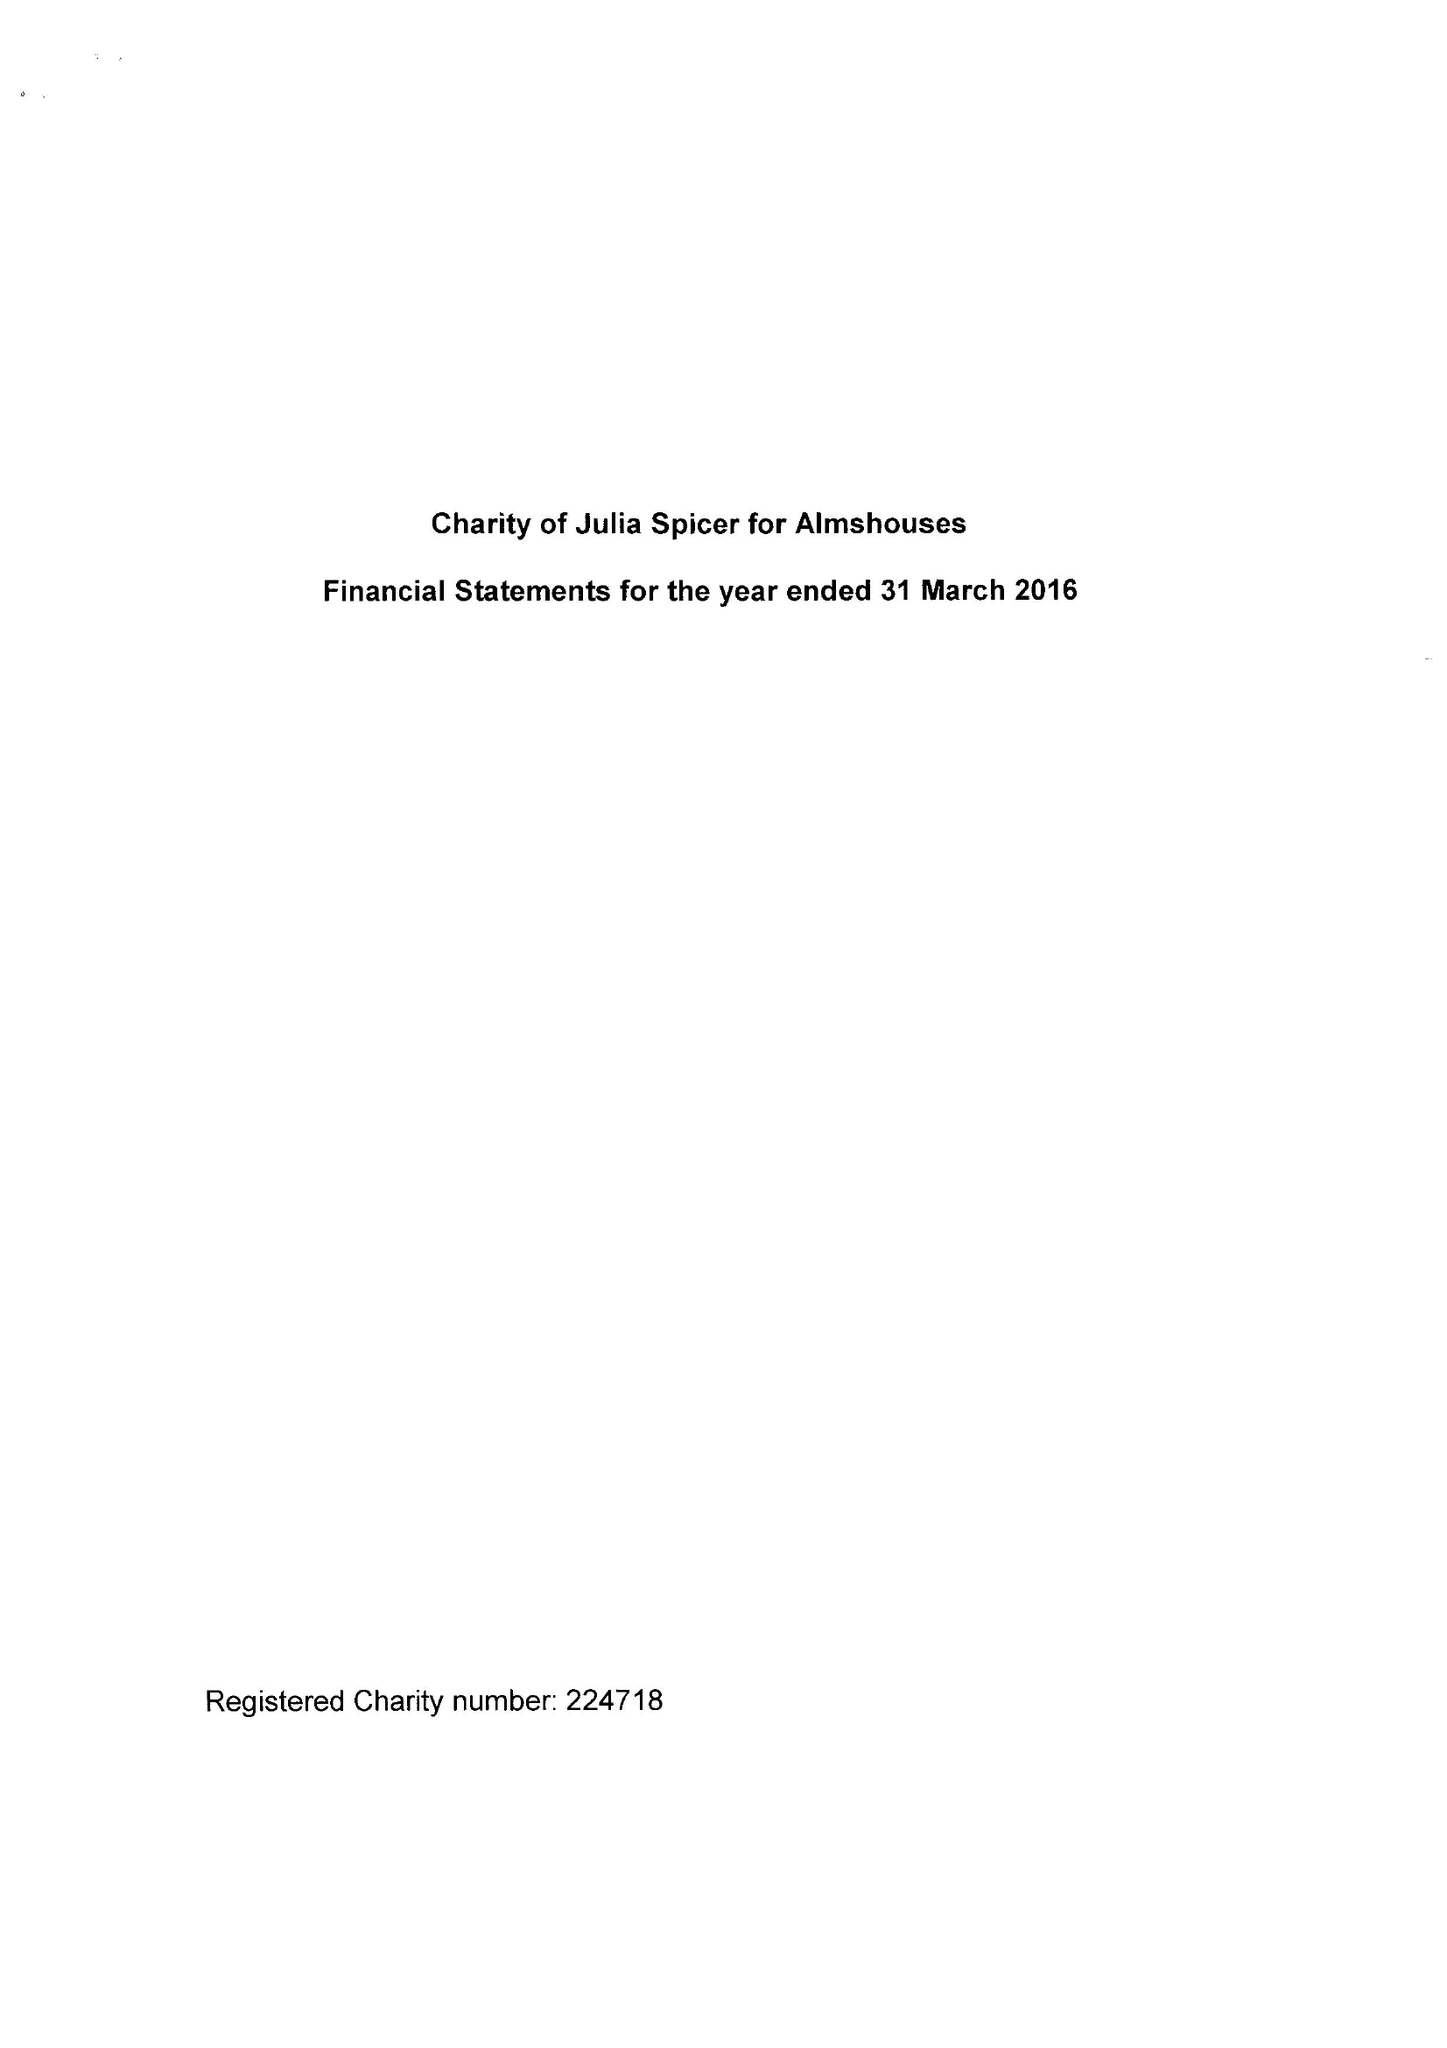What is the value for the charity_name?
Answer the question using a single word or phrase. Charity Of Julia Spicer For Almshouses 